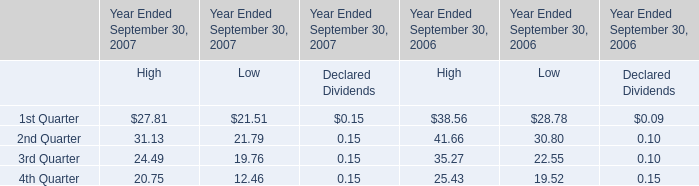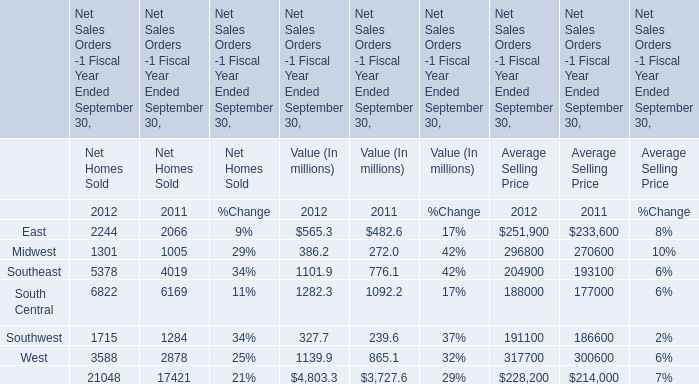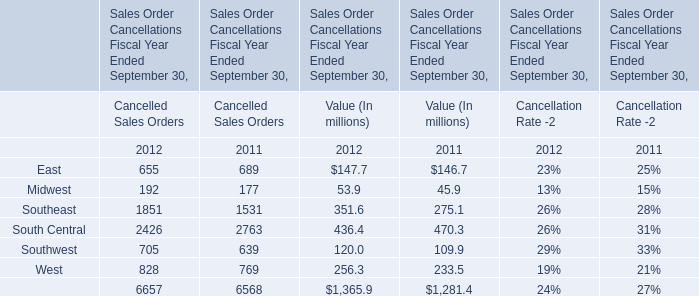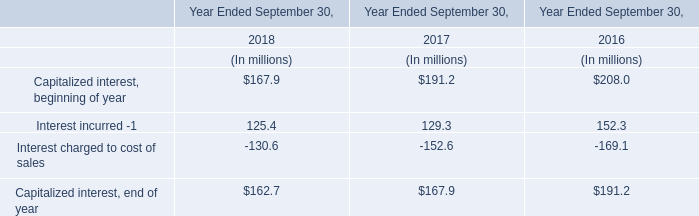When does Southeast reach the largest value in value? 
Answer: 2012. 